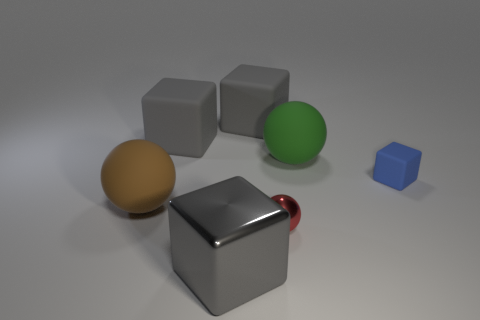There is a large sphere behind the rubber object that is in front of the tiny blue block; how many large brown rubber things are in front of it?
Your answer should be compact. 1. What material is the thing that is on the right side of the red shiny sphere and in front of the large green object?
Offer a terse response. Rubber. There is a sphere that is behind the red metal thing and in front of the tiny rubber cube; what is its color?
Ensure brevity in your answer.  Brown. Is there anything else that is the same color as the tiny sphere?
Your response must be concise. No. There is a big gray thing in front of the matte block right of the tiny object that is left of the blue rubber object; what shape is it?
Make the answer very short. Cube. What is the color of the other rubber object that is the same shape as the green thing?
Provide a short and direct response. Brown. What color is the large ball on the left side of the big matte sphere that is behind the tiny blue rubber thing?
Make the answer very short. Brown. There is another matte thing that is the same shape as the big green thing; what size is it?
Your answer should be compact. Large. What number of green objects are made of the same material as the tiny block?
Keep it short and to the point. 1. What number of things are to the left of the gray cube that is in front of the small ball?
Offer a terse response. 2. 